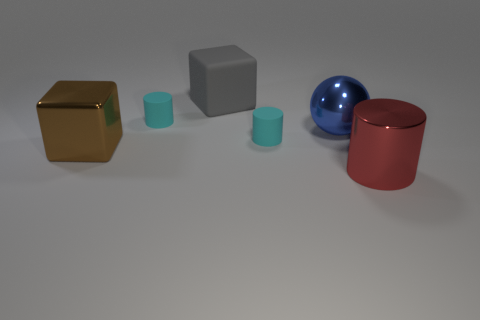Does the metallic cylinder have the same color as the sphere?
Keep it short and to the point. No. How many blue objects are behind the big gray cube?
Ensure brevity in your answer.  0. Do the brown block and the cyan cylinder that is in front of the blue object have the same material?
Provide a succinct answer. No. The brown block that is the same material as the large blue thing is what size?
Your answer should be compact. Large. Is the number of red metallic cylinders that are left of the brown thing greater than the number of big matte cubes that are behind the large gray rubber cube?
Make the answer very short. No. Is there a large red object of the same shape as the gray thing?
Make the answer very short. No. Do the cyan matte thing on the left side of the gray matte thing and the gray cube have the same size?
Offer a very short reply. No. Is there a tiny cyan thing?
Give a very brief answer. Yes. How many objects are either large objects behind the brown shiny object or brown metal objects?
Provide a short and direct response. 3. There is a large metal ball; is its color the same as the tiny cylinder to the left of the gray rubber block?
Offer a terse response. No. 